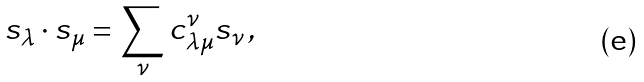Convert formula to latex. <formula><loc_0><loc_0><loc_500><loc_500>s _ { \lambda } \cdot s _ { \mu } = \sum _ { \nu } c _ { \lambda \mu } ^ { \nu } s _ { \nu } \, ,</formula> 